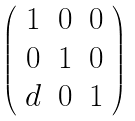<formula> <loc_0><loc_0><loc_500><loc_500>\left ( \begin{array} { c c c } 1 & 0 & 0 \\ 0 & 1 & 0 \\ d & 0 & 1 \end{array} \right )</formula> 